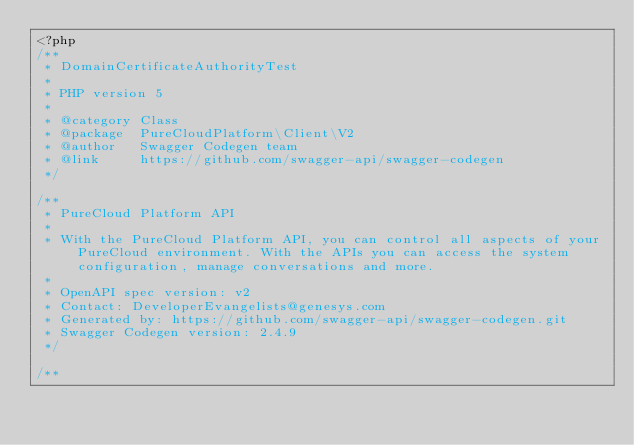<code> <loc_0><loc_0><loc_500><loc_500><_PHP_><?php
/**
 * DomainCertificateAuthorityTest
 *
 * PHP version 5
 *
 * @category Class
 * @package  PureCloudPlatform\Client\V2
 * @author   Swagger Codegen team
 * @link     https://github.com/swagger-api/swagger-codegen
 */

/**
 * PureCloud Platform API
 *
 * With the PureCloud Platform API, you can control all aspects of your PureCloud environment. With the APIs you can access the system configuration, manage conversations and more.
 *
 * OpenAPI spec version: v2
 * Contact: DeveloperEvangelists@genesys.com
 * Generated by: https://github.com/swagger-api/swagger-codegen.git
 * Swagger Codegen version: 2.4.9
 */

/**</code> 